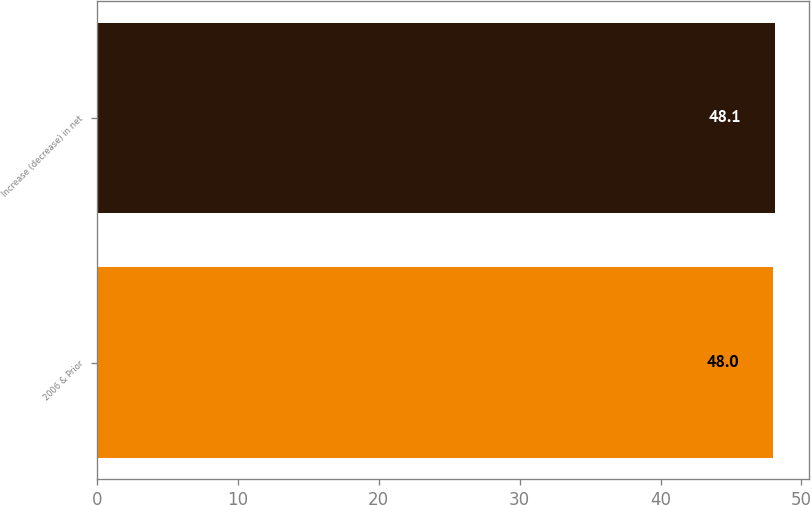Convert chart. <chart><loc_0><loc_0><loc_500><loc_500><bar_chart><fcel>2006 & Prior<fcel>Increase (decrease) in net<nl><fcel>48<fcel>48.1<nl></chart> 